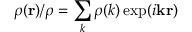<formula> <loc_0><loc_0><loc_500><loc_500>\rho ( { r } ) / \rho = \sum _ { k } \rho ( k ) \exp ( i { k } { r } )</formula> 